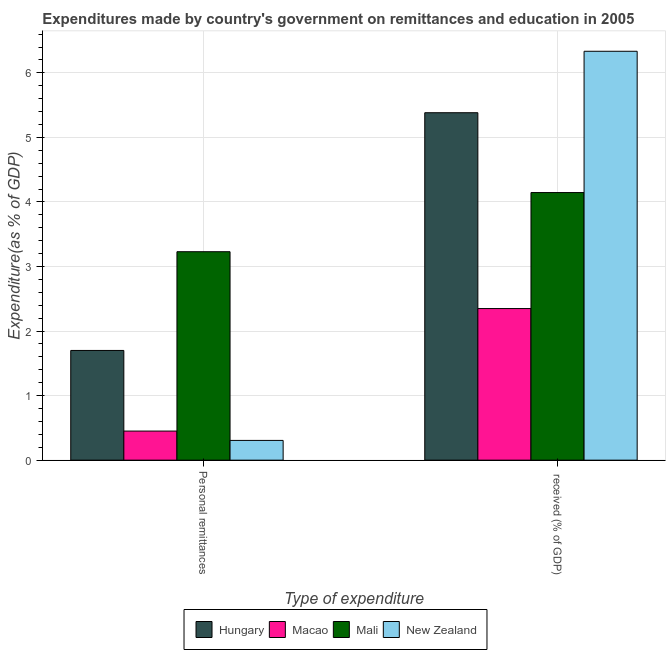How many different coloured bars are there?
Provide a succinct answer. 4. Are the number of bars on each tick of the X-axis equal?
Offer a very short reply. Yes. How many bars are there on the 2nd tick from the left?
Provide a short and direct response. 4. What is the label of the 2nd group of bars from the left?
Make the answer very short.  received (% of GDP). What is the expenditure in education in Macao?
Give a very brief answer. 2.35. Across all countries, what is the maximum expenditure in education?
Make the answer very short. 6.33. Across all countries, what is the minimum expenditure in personal remittances?
Offer a terse response. 0.31. In which country was the expenditure in personal remittances maximum?
Offer a terse response. Mali. In which country was the expenditure in personal remittances minimum?
Offer a terse response. New Zealand. What is the total expenditure in education in the graph?
Provide a succinct answer. 18.21. What is the difference between the expenditure in education in New Zealand and that in Mali?
Give a very brief answer. 2.19. What is the difference between the expenditure in education in Hungary and the expenditure in personal remittances in Mali?
Provide a succinct answer. 2.15. What is the average expenditure in education per country?
Make the answer very short. 4.55. What is the difference between the expenditure in education and expenditure in personal remittances in Macao?
Offer a very short reply. 1.9. What is the ratio of the expenditure in education in Mali to that in Macao?
Keep it short and to the point. 1.77. In how many countries, is the expenditure in education greater than the average expenditure in education taken over all countries?
Ensure brevity in your answer.  2. What does the 2nd bar from the left in Personal remittances represents?
Your response must be concise. Macao. What does the 1st bar from the right in  received (% of GDP) represents?
Offer a terse response. New Zealand. What is the difference between two consecutive major ticks on the Y-axis?
Your answer should be very brief. 1. Does the graph contain any zero values?
Your answer should be compact. No. Does the graph contain grids?
Offer a very short reply. Yes. How many legend labels are there?
Provide a short and direct response. 4. What is the title of the graph?
Your response must be concise. Expenditures made by country's government on remittances and education in 2005. Does "Philippines" appear as one of the legend labels in the graph?
Your answer should be compact. No. What is the label or title of the X-axis?
Provide a short and direct response. Type of expenditure. What is the label or title of the Y-axis?
Keep it short and to the point. Expenditure(as % of GDP). What is the Expenditure(as % of GDP) in Hungary in Personal remittances?
Give a very brief answer. 1.7. What is the Expenditure(as % of GDP) of Macao in Personal remittances?
Offer a very short reply. 0.45. What is the Expenditure(as % of GDP) in Mali in Personal remittances?
Provide a short and direct response. 3.23. What is the Expenditure(as % of GDP) in New Zealand in Personal remittances?
Offer a terse response. 0.31. What is the Expenditure(as % of GDP) in Hungary in  received (% of GDP)?
Provide a succinct answer. 5.38. What is the Expenditure(as % of GDP) in Macao in  received (% of GDP)?
Give a very brief answer. 2.35. What is the Expenditure(as % of GDP) in Mali in  received (% of GDP)?
Offer a terse response. 4.15. What is the Expenditure(as % of GDP) of New Zealand in  received (% of GDP)?
Your response must be concise. 6.33. Across all Type of expenditure, what is the maximum Expenditure(as % of GDP) of Hungary?
Provide a short and direct response. 5.38. Across all Type of expenditure, what is the maximum Expenditure(as % of GDP) of Macao?
Make the answer very short. 2.35. Across all Type of expenditure, what is the maximum Expenditure(as % of GDP) of Mali?
Ensure brevity in your answer.  4.15. Across all Type of expenditure, what is the maximum Expenditure(as % of GDP) of New Zealand?
Provide a short and direct response. 6.33. Across all Type of expenditure, what is the minimum Expenditure(as % of GDP) in Hungary?
Provide a succinct answer. 1.7. Across all Type of expenditure, what is the minimum Expenditure(as % of GDP) in Macao?
Your answer should be very brief. 0.45. Across all Type of expenditure, what is the minimum Expenditure(as % of GDP) in Mali?
Keep it short and to the point. 3.23. Across all Type of expenditure, what is the minimum Expenditure(as % of GDP) in New Zealand?
Provide a short and direct response. 0.31. What is the total Expenditure(as % of GDP) in Hungary in the graph?
Your response must be concise. 7.08. What is the total Expenditure(as % of GDP) of Macao in the graph?
Provide a succinct answer. 2.8. What is the total Expenditure(as % of GDP) in Mali in the graph?
Ensure brevity in your answer.  7.38. What is the total Expenditure(as % of GDP) of New Zealand in the graph?
Provide a succinct answer. 6.64. What is the difference between the Expenditure(as % of GDP) of Hungary in Personal remittances and that in  received (% of GDP)?
Your answer should be compact. -3.68. What is the difference between the Expenditure(as % of GDP) of Macao in Personal remittances and that in  received (% of GDP)?
Provide a short and direct response. -1.9. What is the difference between the Expenditure(as % of GDP) of Mali in Personal remittances and that in  received (% of GDP)?
Give a very brief answer. -0.92. What is the difference between the Expenditure(as % of GDP) in New Zealand in Personal remittances and that in  received (% of GDP)?
Your answer should be very brief. -6.03. What is the difference between the Expenditure(as % of GDP) in Hungary in Personal remittances and the Expenditure(as % of GDP) in Macao in  received (% of GDP)?
Provide a short and direct response. -0.65. What is the difference between the Expenditure(as % of GDP) in Hungary in Personal remittances and the Expenditure(as % of GDP) in Mali in  received (% of GDP)?
Make the answer very short. -2.45. What is the difference between the Expenditure(as % of GDP) of Hungary in Personal remittances and the Expenditure(as % of GDP) of New Zealand in  received (% of GDP)?
Provide a short and direct response. -4.64. What is the difference between the Expenditure(as % of GDP) of Macao in Personal remittances and the Expenditure(as % of GDP) of Mali in  received (% of GDP)?
Your answer should be compact. -3.7. What is the difference between the Expenditure(as % of GDP) in Macao in Personal remittances and the Expenditure(as % of GDP) in New Zealand in  received (% of GDP)?
Give a very brief answer. -5.88. What is the difference between the Expenditure(as % of GDP) in Mali in Personal remittances and the Expenditure(as % of GDP) in New Zealand in  received (% of GDP)?
Make the answer very short. -3.11. What is the average Expenditure(as % of GDP) in Hungary per Type of expenditure?
Ensure brevity in your answer.  3.54. What is the average Expenditure(as % of GDP) in Macao per Type of expenditure?
Your response must be concise. 1.4. What is the average Expenditure(as % of GDP) of Mali per Type of expenditure?
Offer a terse response. 3.69. What is the average Expenditure(as % of GDP) of New Zealand per Type of expenditure?
Offer a very short reply. 3.32. What is the difference between the Expenditure(as % of GDP) of Hungary and Expenditure(as % of GDP) of Macao in Personal remittances?
Provide a short and direct response. 1.25. What is the difference between the Expenditure(as % of GDP) of Hungary and Expenditure(as % of GDP) of Mali in Personal remittances?
Keep it short and to the point. -1.53. What is the difference between the Expenditure(as % of GDP) in Hungary and Expenditure(as % of GDP) in New Zealand in Personal remittances?
Give a very brief answer. 1.39. What is the difference between the Expenditure(as % of GDP) in Macao and Expenditure(as % of GDP) in Mali in Personal remittances?
Provide a succinct answer. -2.78. What is the difference between the Expenditure(as % of GDP) of Macao and Expenditure(as % of GDP) of New Zealand in Personal remittances?
Provide a succinct answer. 0.14. What is the difference between the Expenditure(as % of GDP) of Mali and Expenditure(as % of GDP) of New Zealand in Personal remittances?
Your answer should be very brief. 2.92. What is the difference between the Expenditure(as % of GDP) in Hungary and Expenditure(as % of GDP) in Macao in  received (% of GDP)?
Your answer should be very brief. 3.03. What is the difference between the Expenditure(as % of GDP) of Hungary and Expenditure(as % of GDP) of Mali in  received (% of GDP)?
Your answer should be compact. 1.24. What is the difference between the Expenditure(as % of GDP) in Hungary and Expenditure(as % of GDP) in New Zealand in  received (% of GDP)?
Provide a short and direct response. -0.95. What is the difference between the Expenditure(as % of GDP) in Macao and Expenditure(as % of GDP) in Mali in  received (% of GDP)?
Give a very brief answer. -1.8. What is the difference between the Expenditure(as % of GDP) in Macao and Expenditure(as % of GDP) in New Zealand in  received (% of GDP)?
Give a very brief answer. -3.99. What is the difference between the Expenditure(as % of GDP) of Mali and Expenditure(as % of GDP) of New Zealand in  received (% of GDP)?
Ensure brevity in your answer.  -2.19. What is the ratio of the Expenditure(as % of GDP) in Hungary in Personal remittances to that in  received (% of GDP)?
Ensure brevity in your answer.  0.32. What is the ratio of the Expenditure(as % of GDP) in Macao in Personal remittances to that in  received (% of GDP)?
Your answer should be very brief. 0.19. What is the ratio of the Expenditure(as % of GDP) in Mali in Personal remittances to that in  received (% of GDP)?
Your response must be concise. 0.78. What is the ratio of the Expenditure(as % of GDP) in New Zealand in Personal remittances to that in  received (% of GDP)?
Your answer should be very brief. 0.05. What is the difference between the highest and the second highest Expenditure(as % of GDP) in Hungary?
Give a very brief answer. 3.68. What is the difference between the highest and the second highest Expenditure(as % of GDP) of Macao?
Provide a succinct answer. 1.9. What is the difference between the highest and the second highest Expenditure(as % of GDP) of Mali?
Your response must be concise. 0.92. What is the difference between the highest and the second highest Expenditure(as % of GDP) in New Zealand?
Ensure brevity in your answer.  6.03. What is the difference between the highest and the lowest Expenditure(as % of GDP) of Hungary?
Offer a terse response. 3.68. What is the difference between the highest and the lowest Expenditure(as % of GDP) of Macao?
Offer a terse response. 1.9. What is the difference between the highest and the lowest Expenditure(as % of GDP) in Mali?
Provide a short and direct response. 0.92. What is the difference between the highest and the lowest Expenditure(as % of GDP) in New Zealand?
Your answer should be very brief. 6.03. 